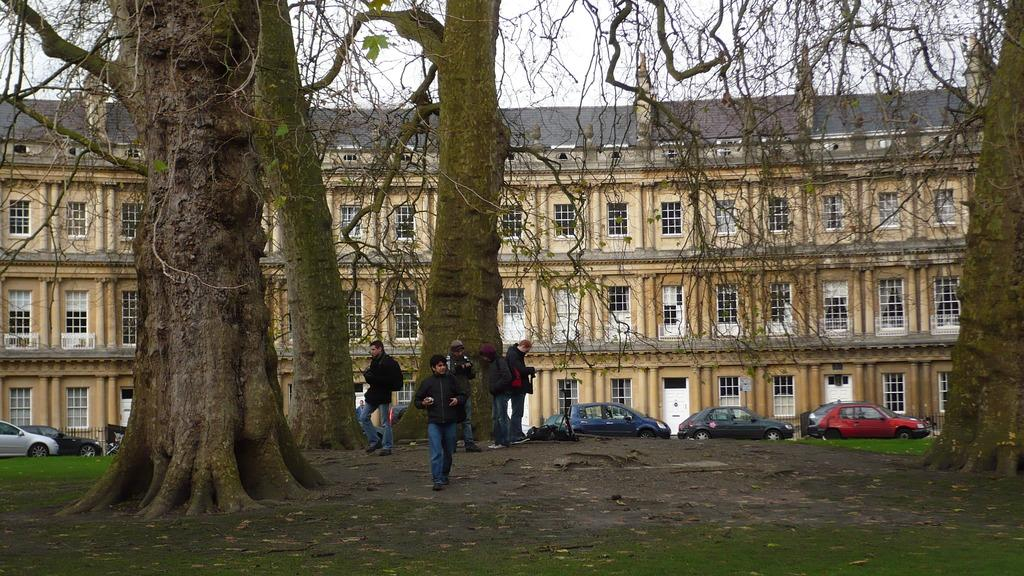How many people are in the image? There is a group of people in the image, but the exact number is not specified. Where are the people located in the image? The people are standing under trees in the image. What else can be seen in the image besides the people? There are vehicles and a building visible in the image. What type of rake is being used by the people in the image? There is no rake present in the image. How comfortable are the people in the image? The image does not provide information about the comfort level of the people. 